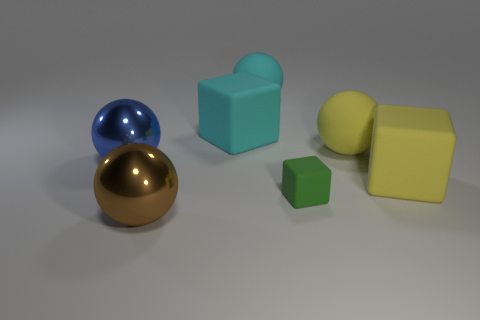What number of other things are there of the same size as the green block?
Provide a succinct answer. 0. What number of large objects are left of the green thing and to the right of the blue metallic object?
Offer a very short reply. 3. There is a rubber cube behind the metallic thing left of the metallic ball that is to the right of the large blue metal object; what color is it?
Offer a very short reply. Cyan. What number of other objects are there of the same shape as the blue thing?
Your response must be concise. 3. There is a big block that is right of the tiny rubber object; is there a big cyan sphere that is right of it?
Provide a succinct answer. No. How many rubber objects are either blue cylinders or brown balls?
Make the answer very short. 0. The thing that is in front of the big yellow block and to the left of the tiny block is made of what material?
Provide a succinct answer. Metal. There is a metal ball in front of the blue object that is on the left side of the green matte thing; is there a yellow object behind it?
Make the answer very short. Yes. Is there any other thing that has the same material as the green block?
Keep it short and to the point. Yes. There is a big cyan object that is made of the same material as the large cyan sphere; what is its shape?
Provide a succinct answer. Cube. 